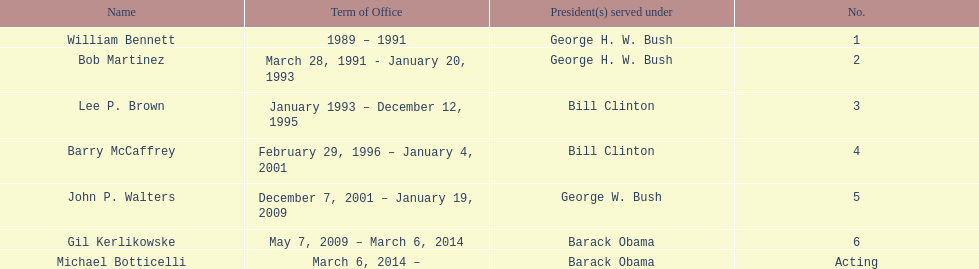How long did the first director serve in office? 2 years. 